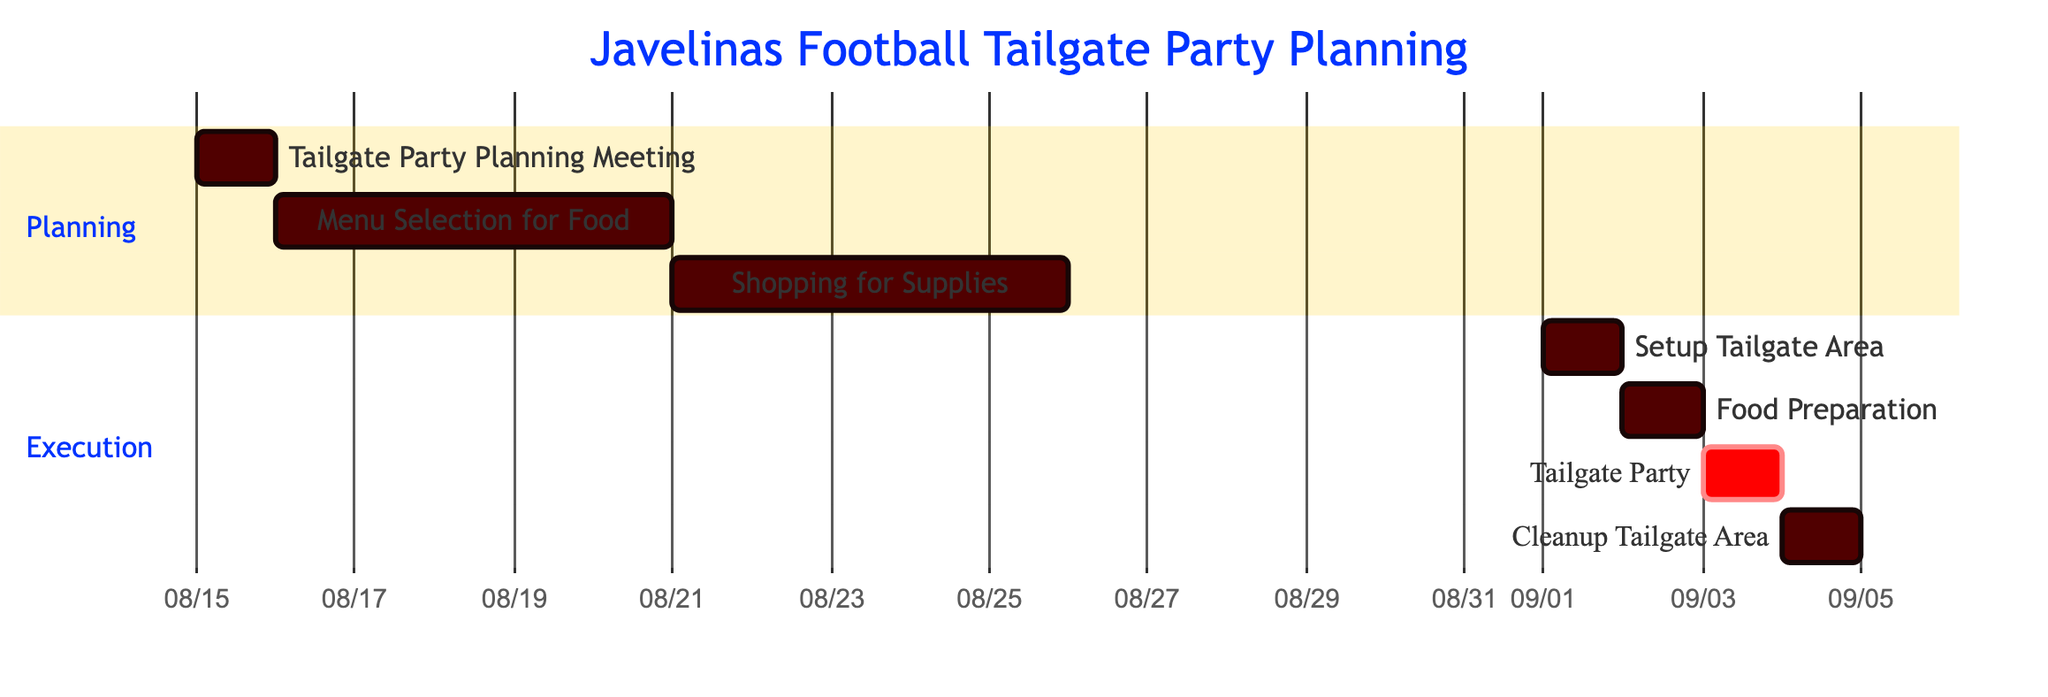What is the duration of the "Menu Selection for Food"? The "Menu Selection for Food" activity starts on August 16, 2023, and ends on August 20, 2023. Counting the days from start to end gives a total of 5 days.
Answer: 5 days When does the "Setup Tailgate Area" begin? The "Setup Tailgate Area" has a specific start date of September 1, 2023, as shown in the diagram.
Answer: September 1, 2023 How many days are there between the "Food Preparation" and the "Tailgate Party"? The "Food Preparation" starts and ends on September 2, 2023, and the "Tailgate Party" starts and ends the next day, September 3, 2023. There are 1 day in between them.
Answer: 1 day What activity occurs immediately before the "Tailgate Party"? In the Gantt chart, the activity that occurs immediately before the "Tailgate Party" is "Food Preparation," which takes place on September 2, 2023.
Answer: Food Preparation What is the total number of activities in the diagram? Summing all the listed activities in the Gantt chart gives us 7 different activities: Planning Meeting, Menu Selection, Shopping for Supplies, Setup, Food Prep, Tailgate Party, and Cleanup.
Answer: 7 activities Which section includes the "Cleanup Tailgate Area"? The "Cleanup Tailgate Area" activity is part of the "Execution" section in the Gantt chart, as per its placement under that specific section title.
Answer: Execution What is the start date of the "Shopping for Supplies"? The "Shopping for Supplies" activity begins on August 21, 2023, as indicated in the timeline of the Gantt chart.
Answer: August 21, 2023 Is the "Tailgate Party" critical in the schedule? The "Tailgate Party" is marked as critical in the Gantt chart, which signifies its importance in the planning and scheduling process for the event.
Answer: Yes 